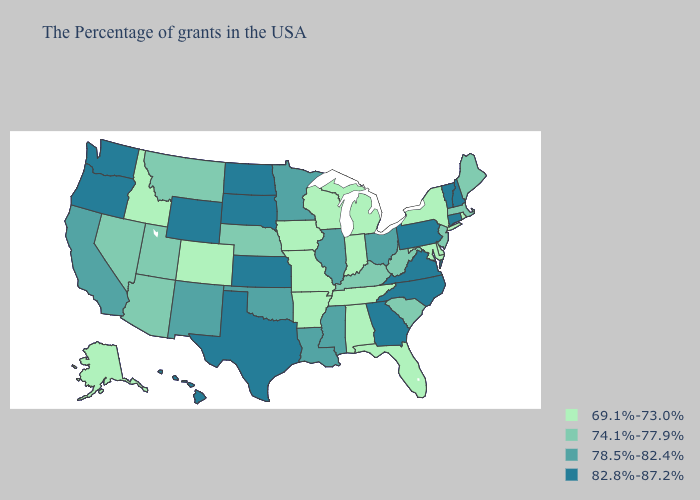What is the value of Texas?
Be succinct. 82.8%-87.2%. What is the lowest value in the Northeast?
Answer briefly. 69.1%-73.0%. What is the value of Arkansas?
Quick response, please. 69.1%-73.0%. Does Nebraska have the highest value in the USA?
Short answer required. No. Name the states that have a value in the range 69.1%-73.0%?
Short answer required. Rhode Island, New York, Delaware, Maryland, Florida, Michigan, Indiana, Alabama, Tennessee, Wisconsin, Missouri, Arkansas, Iowa, Colorado, Idaho, Alaska. Does the first symbol in the legend represent the smallest category?
Give a very brief answer. Yes. What is the value of Minnesota?
Quick response, please. 78.5%-82.4%. What is the value of Idaho?
Keep it brief. 69.1%-73.0%. What is the highest value in the USA?
Quick response, please. 82.8%-87.2%. Does New Hampshire have the highest value in the USA?
Keep it brief. Yes. What is the value of Kansas?
Write a very short answer. 82.8%-87.2%. Which states have the lowest value in the USA?
Short answer required. Rhode Island, New York, Delaware, Maryland, Florida, Michigan, Indiana, Alabama, Tennessee, Wisconsin, Missouri, Arkansas, Iowa, Colorado, Idaho, Alaska. Does the map have missing data?
Be succinct. No. Does Montana have the lowest value in the West?
Write a very short answer. No. Name the states that have a value in the range 74.1%-77.9%?
Short answer required. Maine, Massachusetts, New Jersey, South Carolina, West Virginia, Kentucky, Nebraska, Utah, Montana, Arizona, Nevada. 